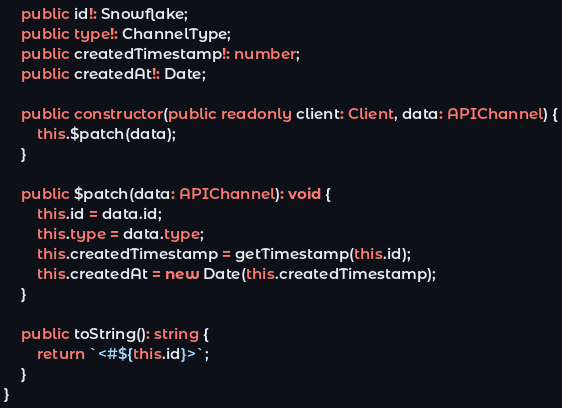<code> <loc_0><loc_0><loc_500><loc_500><_TypeScript_>	public id!: Snowflake;
	public type!: ChannelType;
	public createdTimestamp!: number;
	public createdAt!: Date;

	public constructor(public readonly client: Client, data: APIChannel) {
		this.$patch(data);
	}

	public $patch(data: APIChannel): void {
		this.id = data.id;
		this.type = data.type;
		this.createdTimestamp = getTimestamp(this.id);
		this.createdAt = new Date(this.createdTimestamp);
	}

	public toString(): string {
		return `<#${this.id}>`;
	}
}
</code> 